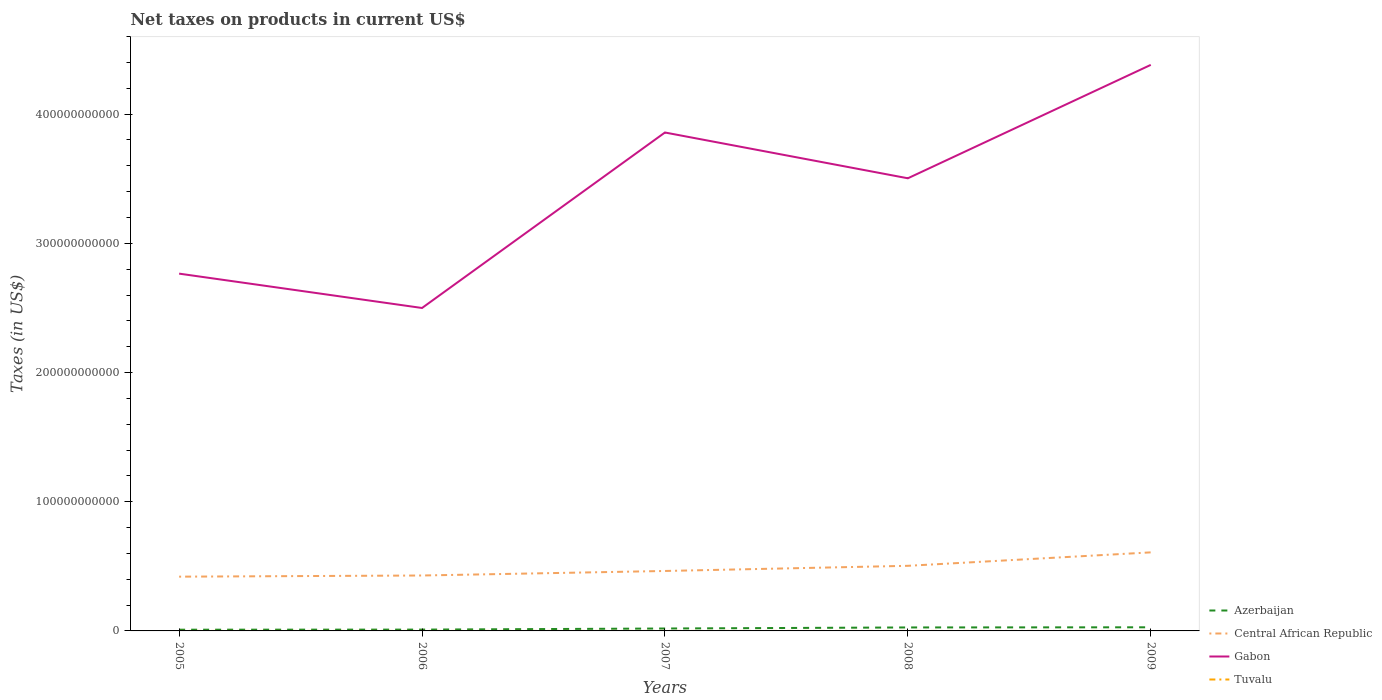Across all years, what is the maximum net taxes on products in Central African Republic?
Offer a terse response. 4.20e+1. In which year was the net taxes on products in Central African Republic maximum?
Your answer should be compact. 2005. What is the total net taxes on products in Azerbaijan in the graph?
Provide a short and direct response. -9.24e+08. What is the difference between the highest and the second highest net taxes on products in Central African Republic?
Make the answer very short. 1.88e+1. What is the difference between the highest and the lowest net taxes on products in Central African Republic?
Keep it short and to the point. 2. Is the net taxes on products in Tuvalu strictly greater than the net taxes on products in Azerbaijan over the years?
Your answer should be very brief. Yes. What is the difference between two consecutive major ticks on the Y-axis?
Offer a very short reply. 1.00e+11. Are the values on the major ticks of Y-axis written in scientific E-notation?
Provide a succinct answer. No. Does the graph contain any zero values?
Ensure brevity in your answer.  No. Where does the legend appear in the graph?
Offer a very short reply. Bottom right. What is the title of the graph?
Make the answer very short. Net taxes on products in current US$. Does "Northern Mariana Islands" appear as one of the legend labels in the graph?
Provide a succinct answer. No. What is the label or title of the Y-axis?
Give a very brief answer. Taxes (in US$). What is the Taxes (in US$) of Azerbaijan in 2005?
Ensure brevity in your answer.  9.46e+08. What is the Taxes (in US$) in Central African Republic in 2005?
Your answer should be very brief. 4.20e+1. What is the Taxes (in US$) of Gabon in 2005?
Your answer should be compact. 2.77e+11. What is the Taxes (in US$) of Tuvalu in 2005?
Make the answer very short. 2.79e+06. What is the Taxes (in US$) in Azerbaijan in 2006?
Ensure brevity in your answer.  1.02e+09. What is the Taxes (in US$) in Central African Republic in 2006?
Keep it short and to the point. 4.29e+1. What is the Taxes (in US$) of Gabon in 2006?
Your answer should be compact. 2.50e+11. What is the Taxes (in US$) in Tuvalu in 2006?
Offer a terse response. 2.62e+06. What is the Taxes (in US$) in Azerbaijan in 2007?
Your answer should be very brief. 1.87e+09. What is the Taxes (in US$) of Central African Republic in 2007?
Your answer should be very brief. 4.64e+1. What is the Taxes (in US$) in Gabon in 2007?
Your answer should be very brief. 3.86e+11. What is the Taxes (in US$) of Tuvalu in 2007?
Your response must be concise. 2.78e+06. What is the Taxes (in US$) in Azerbaijan in 2008?
Your response must be concise. 2.69e+09. What is the Taxes (in US$) in Central African Republic in 2008?
Your answer should be very brief. 5.04e+1. What is the Taxes (in US$) in Gabon in 2008?
Give a very brief answer. 3.50e+11. What is the Taxes (in US$) of Tuvalu in 2008?
Provide a succinct answer. 3.17e+06. What is the Taxes (in US$) in Azerbaijan in 2009?
Your response must be concise. 2.81e+09. What is the Taxes (in US$) of Central African Republic in 2009?
Provide a short and direct response. 6.08e+1. What is the Taxes (in US$) of Gabon in 2009?
Provide a succinct answer. 4.38e+11. What is the Taxes (in US$) of Tuvalu in 2009?
Ensure brevity in your answer.  2.72e+06. Across all years, what is the maximum Taxes (in US$) of Azerbaijan?
Provide a short and direct response. 2.81e+09. Across all years, what is the maximum Taxes (in US$) of Central African Republic?
Provide a succinct answer. 6.08e+1. Across all years, what is the maximum Taxes (in US$) in Gabon?
Offer a terse response. 4.38e+11. Across all years, what is the maximum Taxes (in US$) in Tuvalu?
Provide a succinct answer. 3.17e+06. Across all years, what is the minimum Taxes (in US$) in Azerbaijan?
Your answer should be compact. 9.46e+08. Across all years, what is the minimum Taxes (in US$) in Central African Republic?
Make the answer very short. 4.20e+1. Across all years, what is the minimum Taxes (in US$) of Gabon?
Provide a succinct answer. 2.50e+11. Across all years, what is the minimum Taxes (in US$) of Tuvalu?
Your answer should be very brief. 2.62e+06. What is the total Taxes (in US$) in Azerbaijan in the graph?
Offer a terse response. 9.34e+09. What is the total Taxes (in US$) of Central African Republic in the graph?
Your answer should be very brief. 2.42e+11. What is the total Taxes (in US$) of Gabon in the graph?
Ensure brevity in your answer.  1.70e+12. What is the total Taxes (in US$) in Tuvalu in the graph?
Provide a short and direct response. 1.41e+07. What is the difference between the Taxes (in US$) of Azerbaijan in 2005 and that in 2006?
Your response must be concise. -7.79e+07. What is the difference between the Taxes (in US$) in Central African Republic in 2005 and that in 2006?
Offer a very short reply. -9.00e+08. What is the difference between the Taxes (in US$) in Gabon in 2005 and that in 2006?
Offer a terse response. 2.66e+1. What is the difference between the Taxes (in US$) of Tuvalu in 2005 and that in 2006?
Your response must be concise. 1.68e+05. What is the difference between the Taxes (in US$) in Azerbaijan in 2005 and that in 2007?
Give a very brief answer. -9.24e+08. What is the difference between the Taxes (in US$) in Central African Republic in 2005 and that in 2007?
Give a very brief answer. -4.40e+09. What is the difference between the Taxes (in US$) in Gabon in 2005 and that in 2007?
Your answer should be very brief. -1.09e+11. What is the difference between the Taxes (in US$) of Tuvalu in 2005 and that in 2007?
Provide a succinct answer. 3800. What is the difference between the Taxes (in US$) of Azerbaijan in 2005 and that in 2008?
Offer a very short reply. -1.74e+09. What is the difference between the Taxes (in US$) of Central African Republic in 2005 and that in 2008?
Your answer should be very brief. -8.40e+09. What is the difference between the Taxes (in US$) in Gabon in 2005 and that in 2008?
Keep it short and to the point. -7.38e+1. What is the difference between the Taxes (in US$) of Tuvalu in 2005 and that in 2008?
Your answer should be very brief. -3.78e+05. What is the difference between the Taxes (in US$) of Azerbaijan in 2005 and that in 2009?
Offer a very short reply. -1.86e+09. What is the difference between the Taxes (in US$) of Central African Republic in 2005 and that in 2009?
Give a very brief answer. -1.88e+1. What is the difference between the Taxes (in US$) in Gabon in 2005 and that in 2009?
Your answer should be very brief. -1.62e+11. What is the difference between the Taxes (in US$) in Tuvalu in 2005 and that in 2009?
Provide a short and direct response. 7.28e+04. What is the difference between the Taxes (in US$) of Azerbaijan in 2006 and that in 2007?
Your answer should be compact. -8.46e+08. What is the difference between the Taxes (in US$) in Central African Republic in 2006 and that in 2007?
Keep it short and to the point. -3.50e+09. What is the difference between the Taxes (in US$) in Gabon in 2006 and that in 2007?
Provide a succinct answer. -1.36e+11. What is the difference between the Taxes (in US$) in Tuvalu in 2006 and that in 2007?
Give a very brief answer. -1.64e+05. What is the difference between the Taxes (in US$) in Azerbaijan in 2006 and that in 2008?
Give a very brief answer. -1.66e+09. What is the difference between the Taxes (in US$) in Central African Republic in 2006 and that in 2008?
Ensure brevity in your answer.  -7.50e+09. What is the difference between the Taxes (in US$) in Gabon in 2006 and that in 2008?
Offer a terse response. -1.00e+11. What is the difference between the Taxes (in US$) of Tuvalu in 2006 and that in 2008?
Give a very brief answer. -5.46e+05. What is the difference between the Taxes (in US$) in Azerbaijan in 2006 and that in 2009?
Your answer should be very brief. -1.79e+09. What is the difference between the Taxes (in US$) in Central African Republic in 2006 and that in 2009?
Make the answer very short. -1.79e+1. What is the difference between the Taxes (in US$) of Gabon in 2006 and that in 2009?
Your response must be concise. -1.88e+11. What is the difference between the Taxes (in US$) in Tuvalu in 2006 and that in 2009?
Offer a very short reply. -9.50e+04. What is the difference between the Taxes (in US$) of Azerbaijan in 2007 and that in 2008?
Your answer should be compact. -8.18e+08. What is the difference between the Taxes (in US$) in Central African Republic in 2007 and that in 2008?
Make the answer very short. -4.00e+09. What is the difference between the Taxes (in US$) of Gabon in 2007 and that in 2008?
Your response must be concise. 3.54e+1. What is the difference between the Taxes (in US$) of Tuvalu in 2007 and that in 2008?
Ensure brevity in your answer.  -3.82e+05. What is the difference between the Taxes (in US$) in Azerbaijan in 2007 and that in 2009?
Offer a very short reply. -9.40e+08. What is the difference between the Taxes (in US$) of Central African Republic in 2007 and that in 2009?
Offer a very short reply. -1.44e+1. What is the difference between the Taxes (in US$) of Gabon in 2007 and that in 2009?
Keep it short and to the point. -5.23e+1. What is the difference between the Taxes (in US$) in Tuvalu in 2007 and that in 2009?
Give a very brief answer. 6.90e+04. What is the difference between the Taxes (in US$) in Azerbaijan in 2008 and that in 2009?
Provide a short and direct response. -1.21e+08. What is the difference between the Taxes (in US$) of Central African Republic in 2008 and that in 2009?
Make the answer very short. -1.04e+1. What is the difference between the Taxes (in US$) in Gabon in 2008 and that in 2009?
Offer a terse response. -8.78e+1. What is the difference between the Taxes (in US$) of Tuvalu in 2008 and that in 2009?
Make the answer very short. 4.51e+05. What is the difference between the Taxes (in US$) of Azerbaijan in 2005 and the Taxes (in US$) of Central African Republic in 2006?
Your answer should be very brief. -4.20e+1. What is the difference between the Taxes (in US$) of Azerbaijan in 2005 and the Taxes (in US$) of Gabon in 2006?
Your answer should be very brief. -2.49e+11. What is the difference between the Taxes (in US$) of Azerbaijan in 2005 and the Taxes (in US$) of Tuvalu in 2006?
Offer a terse response. 9.44e+08. What is the difference between the Taxes (in US$) in Central African Republic in 2005 and the Taxes (in US$) in Gabon in 2006?
Your answer should be very brief. -2.08e+11. What is the difference between the Taxes (in US$) in Central African Republic in 2005 and the Taxes (in US$) in Tuvalu in 2006?
Provide a short and direct response. 4.20e+1. What is the difference between the Taxes (in US$) of Gabon in 2005 and the Taxes (in US$) of Tuvalu in 2006?
Provide a succinct answer. 2.77e+11. What is the difference between the Taxes (in US$) of Azerbaijan in 2005 and the Taxes (in US$) of Central African Republic in 2007?
Provide a short and direct response. -4.55e+1. What is the difference between the Taxes (in US$) in Azerbaijan in 2005 and the Taxes (in US$) in Gabon in 2007?
Offer a terse response. -3.85e+11. What is the difference between the Taxes (in US$) of Azerbaijan in 2005 and the Taxes (in US$) of Tuvalu in 2007?
Make the answer very short. 9.44e+08. What is the difference between the Taxes (in US$) in Central African Republic in 2005 and the Taxes (in US$) in Gabon in 2007?
Make the answer very short. -3.44e+11. What is the difference between the Taxes (in US$) of Central African Republic in 2005 and the Taxes (in US$) of Tuvalu in 2007?
Offer a terse response. 4.20e+1. What is the difference between the Taxes (in US$) of Gabon in 2005 and the Taxes (in US$) of Tuvalu in 2007?
Your answer should be very brief. 2.77e+11. What is the difference between the Taxes (in US$) of Azerbaijan in 2005 and the Taxes (in US$) of Central African Republic in 2008?
Offer a very short reply. -4.95e+1. What is the difference between the Taxes (in US$) in Azerbaijan in 2005 and the Taxes (in US$) in Gabon in 2008?
Offer a very short reply. -3.49e+11. What is the difference between the Taxes (in US$) of Azerbaijan in 2005 and the Taxes (in US$) of Tuvalu in 2008?
Provide a succinct answer. 9.43e+08. What is the difference between the Taxes (in US$) in Central African Republic in 2005 and the Taxes (in US$) in Gabon in 2008?
Your answer should be very brief. -3.08e+11. What is the difference between the Taxes (in US$) of Central African Republic in 2005 and the Taxes (in US$) of Tuvalu in 2008?
Your answer should be compact. 4.20e+1. What is the difference between the Taxes (in US$) of Gabon in 2005 and the Taxes (in US$) of Tuvalu in 2008?
Keep it short and to the point. 2.77e+11. What is the difference between the Taxes (in US$) in Azerbaijan in 2005 and the Taxes (in US$) in Central African Republic in 2009?
Keep it short and to the point. -5.99e+1. What is the difference between the Taxes (in US$) in Azerbaijan in 2005 and the Taxes (in US$) in Gabon in 2009?
Your response must be concise. -4.37e+11. What is the difference between the Taxes (in US$) of Azerbaijan in 2005 and the Taxes (in US$) of Tuvalu in 2009?
Give a very brief answer. 9.44e+08. What is the difference between the Taxes (in US$) in Central African Republic in 2005 and the Taxes (in US$) in Gabon in 2009?
Your answer should be compact. -3.96e+11. What is the difference between the Taxes (in US$) of Central African Republic in 2005 and the Taxes (in US$) of Tuvalu in 2009?
Give a very brief answer. 4.20e+1. What is the difference between the Taxes (in US$) of Gabon in 2005 and the Taxes (in US$) of Tuvalu in 2009?
Make the answer very short. 2.77e+11. What is the difference between the Taxes (in US$) of Azerbaijan in 2006 and the Taxes (in US$) of Central African Republic in 2007?
Keep it short and to the point. -4.54e+1. What is the difference between the Taxes (in US$) of Azerbaijan in 2006 and the Taxes (in US$) of Gabon in 2007?
Your response must be concise. -3.85e+11. What is the difference between the Taxes (in US$) of Azerbaijan in 2006 and the Taxes (in US$) of Tuvalu in 2007?
Provide a short and direct response. 1.02e+09. What is the difference between the Taxes (in US$) of Central African Republic in 2006 and the Taxes (in US$) of Gabon in 2007?
Offer a terse response. -3.43e+11. What is the difference between the Taxes (in US$) of Central African Republic in 2006 and the Taxes (in US$) of Tuvalu in 2007?
Make the answer very short. 4.29e+1. What is the difference between the Taxes (in US$) of Gabon in 2006 and the Taxes (in US$) of Tuvalu in 2007?
Give a very brief answer. 2.50e+11. What is the difference between the Taxes (in US$) of Azerbaijan in 2006 and the Taxes (in US$) of Central African Republic in 2008?
Give a very brief answer. -4.94e+1. What is the difference between the Taxes (in US$) in Azerbaijan in 2006 and the Taxes (in US$) in Gabon in 2008?
Your answer should be very brief. -3.49e+11. What is the difference between the Taxes (in US$) in Azerbaijan in 2006 and the Taxes (in US$) in Tuvalu in 2008?
Ensure brevity in your answer.  1.02e+09. What is the difference between the Taxes (in US$) of Central African Republic in 2006 and the Taxes (in US$) of Gabon in 2008?
Give a very brief answer. -3.07e+11. What is the difference between the Taxes (in US$) of Central African Republic in 2006 and the Taxes (in US$) of Tuvalu in 2008?
Provide a short and direct response. 4.29e+1. What is the difference between the Taxes (in US$) of Gabon in 2006 and the Taxes (in US$) of Tuvalu in 2008?
Provide a succinct answer. 2.50e+11. What is the difference between the Taxes (in US$) in Azerbaijan in 2006 and the Taxes (in US$) in Central African Republic in 2009?
Ensure brevity in your answer.  -5.98e+1. What is the difference between the Taxes (in US$) of Azerbaijan in 2006 and the Taxes (in US$) of Gabon in 2009?
Make the answer very short. -4.37e+11. What is the difference between the Taxes (in US$) in Azerbaijan in 2006 and the Taxes (in US$) in Tuvalu in 2009?
Ensure brevity in your answer.  1.02e+09. What is the difference between the Taxes (in US$) of Central African Republic in 2006 and the Taxes (in US$) of Gabon in 2009?
Your answer should be compact. -3.95e+11. What is the difference between the Taxes (in US$) of Central African Republic in 2006 and the Taxes (in US$) of Tuvalu in 2009?
Offer a terse response. 4.29e+1. What is the difference between the Taxes (in US$) in Gabon in 2006 and the Taxes (in US$) in Tuvalu in 2009?
Make the answer very short. 2.50e+11. What is the difference between the Taxes (in US$) in Azerbaijan in 2007 and the Taxes (in US$) in Central African Republic in 2008?
Provide a succinct answer. -4.85e+1. What is the difference between the Taxes (in US$) in Azerbaijan in 2007 and the Taxes (in US$) in Gabon in 2008?
Keep it short and to the point. -3.48e+11. What is the difference between the Taxes (in US$) of Azerbaijan in 2007 and the Taxes (in US$) of Tuvalu in 2008?
Your answer should be very brief. 1.87e+09. What is the difference between the Taxes (in US$) in Central African Republic in 2007 and the Taxes (in US$) in Gabon in 2008?
Give a very brief answer. -3.04e+11. What is the difference between the Taxes (in US$) in Central African Republic in 2007 and the Taxes (in US$) in Tuvalu in 2008?
Your answer should be very brief. 4.64e+1. What is the difference between the Taxes (in US$) of Gabon in 2007 and the Taxes (in US$) of Tuvalu in 2008?
Provide a short and direct response. 3.86e+11. What is the difference between the Taxes (in US$) in Azerbaijan in 2007 and the Taxes (in US$) in Central African Republic in 2009?
Offer a terse response. -5.89e+1. What is the difference between the Taxes (in US$) in Azerbaijan in 2007 and the Taxes (in US$) in Gabon in 2009?
Your response must be concise. -4.36e+11. What is the difference between the Taxes (in US$) of Azerbaijan in 2007 and the Taxes (in US$) of Tuvalu in 2009?
Offer a very short reply. 1.87e+09. What is the difference between the Taxes (in US$) of Central African Republic in 2007 and the Taxes (in US$) of Gabon in 2009?
Make the answer very short. -3.92e+11. What is the difference between the Taxes (in US$) of Central African Republic in 2007 and the Taxes (in US$) of Tuvalu in 2009?
Your response must be concise. 4.64e+1. What is the difference between the Taxes (in US$) of Gabon in 2007 and the Taxes (in US$) of Tuvalu in 2009?
Keep it short and to the point. 3.86e+11. What is the difference between the Taxes (in US$) in Azerbaijan in 2008 and the Taxes (in US$) in Central African Republic in 2009?
Give a very brief answer. -5.81e+1. What is the difference between the Taxes (in US$) of Azerbaijan in 2008 and the Taxes (in US$) of Gabon in 2009?
Offer a terse response. -4.35e+11. What is the difference between the Taxes (in US$) of Azerbaijan in 2008 and the Taxes (in US$) of Tuvalu in 2009?
Your answer should be compact. 2.69e+09. What is the difference between the Taxes (in US$) of Central African Republic in 2008 and the Taxes (in US$) of Gabon in 2009?
Your response must be concise. -3.88e+11. What is the difference between the Taxes (in US$) of Central African Republic in 2008 and the Taxes (in US$) of Tuvalu in 2009?
Provide a short and direct response. 5.04e+1. What is the difference between the Taxes (in US$) of Gabon in 2008 and the Taxes (in US$) of Tuvalu in 2009?
Your response must be concise. 3.50e+11. What is the average Taxes (in US$) in Azerbaijan per year?
Offer a very short reply. 1.87e+09. What is the average Taxes (in US$) of Central African Republic per year?
Your response must be concise. 4.85e+1. What is the average Taxes (in US$) of Gabon per year?
Ensure brevity in your answer.  3.40e+11. What is the average Taxes (in US$) in Tuvalu per year?
Your answer should be compact. 2.81e+06. In the year 2005, what is the difference between the Taxes (in US$) in Azerbaijan and Taxes (in US$) in Central African Republic?
Offer a terse response. -4.11e+1. In the year 2005, what is the difference between the Taxes (in US$) of Azerbaijan and Taxes (in US$) of Gabon?
Make the answer very short. -2.76e+11. In the year 2005, what is the difference between the Taxes (in US$) in Azerbaijan and Taxes (in US$) in Tuvalu?
Provide a short and direct response. 9.44e+08. In the year 2005, what is the difference between the Taxes (in US$) of Central African Republic and Taxes (in US$) of Gabon?
Your answer should be very brief. -2.35e+11. In the year 2005, what is the difference between the Taxes (in US$) in Central African Republic and Taxes (in US$) in Tuvalu?
Give a very brief answer. 4.20e+1. In the year 2005, what is the difference between the Taxes (in US$) in Gabon and Taxes (in US$) in Tuvalu?
Your answer should be compact. 2.77e+11. In the year 2006, what is the difference between the Taxes (in US$) in Azerbaijan and Taxes (in US$) in Central African Republic?
Your answer should be very brief. -4.19e+1. In the year 2006, what is the difference between the Taxes (in US$) in Azerbaijan and Taxes (in US$) in Gabon?
Provide a succinct answer. -2.49e+11. In the year 2006, what is the difference between the Taxes (in US$) of Azerbaijan and Taxes (in US$) of Tuvalu?
Make the answer very short. 1.02e+09. In the year 2006, what is the difference between the Taxes (in US$) in Central African Republic and Taxes (in US$) in Gabon?
Make the answer very short. -2.07e+11. In the year 2006, what is the difference between the Taxes (in US$) in Central African Republic and Taxes (in US$) in Tuvalu?
Your answer should be compact. 4.29e+1. In the year 2006, what is the difference between the Taxes (in US$) of Gabon and Taxes (in US$) of Tuvalu?
Your response must be concise. 2.50e+11. In the year 2007, what is the difference between the Taxes (in US$) in Azerbaijan and Taxes (in US$) in Central African Republic?
Keep it short and to the point. -4.45e+1. In the year 2007, what is the difference between the Taxes (in US$) of Azerbaijan and Taxes (in US$) of Gabon?
Your answer should be very brief. -3.84e+11. In the year 2007, what is the difference between the Taxes (in US$) of Azerbaijan and Taxes (in US$) of Tuvalu?
Your response must be concise. 1.87e+09. In the year 2007, what is the difference between the Taxes (in US$) in Central African Republic and Taxes (in US$) in Gabon?
Give a very brief answer. -3.39e+11. In the year 2007, what is the difference between the Taxes (in US$) in Central African Republic and Taxes (in US$) in Tuvalu?
Your response must be concise. 4.64e+1. In the year 2007, what is the difference between the Taxes (in US$) in Gabon and Taxes (in US$) in Tuvalu?
Your answer should be compact. 3.86e+11. In the year 2008, what is the difference between the Taxes (in US$) in Azerbaijan and Taxes (in US$) in Central African Republic?
Ensure brevity in your answer.  -4.77e+1. In the year 2008, what is the difference between the Taxes (in US$) of Azerbaijan and Taxes (in US$) of Gabon?
Offer a very short reply. -3.48e+11. In the year 2008, what is the difference between the Taxes (in US$) in Azerbaijan and Taxes (in US$) in Tuvalu?
Keep it short and to the point. 2.69e+09. In the year 2008, what is the difference between the Taxes (in US$) of Central African Republic and Taxes (in US$) of Gabon?
Provide a succinct answer. -3.00e+11. In the year 2008, what is the difference between the Taxes (in US$) of Central African Republic and Taxes (in US$) of Tuvalu?
Give a very brief answer. 5.04e+1. In the year 2008, what is the difference between the Taxes (in US$) in Gabon and Taxes (in US$) in Tuvalu?
Give a very brief answer. 3.50e+11. In the year 2009, what is the difference between the Taxes (in US$) of Azerbaijan and Taxes (in US$) of Central African Republic?
Provide a short and direct response. -5.80e+1. In the year 2009, what is the difference between the Taxes (in US$) of Azerbaijan and Taxes (in US$) of Gabon?
Your answer should be compact. -4.35e+11. In the year 2009, what is the difference between the Taxes (in US$) of Azerbaijan and Taxes (in US$) of Tuvalu?
Ensure brevity in your answer.  2.81e+09. In the year 2009, what is the difference between the Taxes (in US$) of Central African Republic and Taxes (in US$) of Gabon?
Your answer should be compact. -3.77e+11. In the year 2009, what is the difference between the Taxes (in US$) in Central African Republic and Taxes (in US$) in Tuvalu?
Your answer should be very brief. 6.08e+1. In the year 2009, what is the difference between the Taxes (in US$) of Gabon and Taxes (in US$) of Tuvalu?
Your response must be concise. 4.38e+11. What is the ratio of the Taxes (in US$) of Azerbaijan in 2005 to that in 2006?
Offer a very short reply. 0.92. What is the ratio of the Taxes (in US$) of Central African Republic in 2005 to that in 2006?
Ensure brevity in your answer.  0.98. What is the ratio of the Taxes (in US$) of Gabon in 2005 to that in 2006?
Keep it short and to the point. 1.11. What is the ratio of the Taxes (in US$) in Tuvalu in 2005 to that in 2006?
Provide a short and direct response. 1.06. What is the ratio of the Taxes (in US$) of Azerbaijan in 2005 to that in 2007?
Provide a succinct answer. 0.51. What is the ratio of the Taxes (in US$) in Central African Republic in 2005 to that in 2007?
Your answer should be very brief. 0.91. What is the ratio of the Taxes (in US$) of Gabon in 2005 to that in 2007?
Give a very brief answer. 0.72. What is the ratio of the Taxes (in US$) of Tuvalu in 2005 to that in 2007?
Your response must be concise. 1. What is the ratio of the Taxes (in US$) of Azerbaijan in 2005 to that in 2008?
Keep it short and to the point. 0.35. What is the ratio of the Taxes (in US$) of Central African Republic in 2005 to that in 2008?
Offer a very short reply. 0.83. What is the ratio of the Taxes (in US$) of Gabon in 2005 to that in 2008?
Ensure brevity in your answer.  0.79. What is the ratio of the Taxes (in US$) in Tuvalu in 2005 to that in 2008?
Ensure brevity in your answer.  0.88. What is the ratio of the Taxes (in US$) of Azerbaijan in 2005 to that in 2009?
Your answer should be very brief. 0.34. What is the ratio of the Taxes (in US$) in Central African Republic in 2005 to that in 2009?
Your response must be concise. 0.69. What is the ratio of the Taxes (in US$) in Gabon in 2005 to that in 2009?
Provide a short and direct response. 0.63. What is the ratio of the Taxes (in US$) in Tuvalu in 2005 to that in 2009?
Provide a succinct answer. 1.03. What is the ratio of the Taxes (in US$) of Azerbaijan in 2006 to that in 2007?
Give a very brief answer. 0.55. What is the ratio of the Taxes (in US$) of Central African Republic in 2006 to that in 2007?
Make the answer very short. 0.92. What is the ratio of the Taxes (in US$) in Gabon in 2006 to that in 2007?
Your answer should be compact. 0.65. What is the ratio of the Taxes (in US$) in Tuvalu in 2006 to that in 2007?
Your answer should be compact. 0.94. What is the ratio of the Taxes (in US$) in Azerbaijan in 2006 to that in 2008?
Your answer should be compact. 0.38. What is the ratio of the Taxes (in US$) in Central African Republic in 2006 to that in 2008?
Give a very brief answer. 0.85. What is the ratio of the Taxes (in US$) of Gabon in 2006 to that in 2008?
Give a very brief answer. 0.71. What is the ratio of the Taxes (in US$) in Tuvalu in 2006 to that in 2008?
Your answer should be very brief. 0.83. What is the ratio of the Taxes (in US$) of Azerbaijan in 2006 to that in 2009?
Give a very brief answer. 0.36. What is the ratio of the Taxes (in US$) in Central African Republic in 2006 to that in 2009?
Your answer should be compact. 0.71. What is the ratio of the Taxes (in US$) of Gabon in 2006 to that in 2009?
Provide a succinct answer. 0.57. What is the ratio of the Taxes (in US$) in Azerbaijan in 2007 to that in 2008?
Ensure brevity in your answer.  0.7. What is the ratio of the Taxes (in US$) in Central African Republic in 2007 to that in 2008?
Offer a very short reply. 0.92. What is the ratio of the Taxes (in US$) of Gabon in 2007 to that in 2008?
Keep it short and to the point. 1.1. What is the ratio of the Taxes (in US$) in Tuvalu in 2007 to that in 2008?
Provide a short and direct response. 0.88. What is the ratio of the Taxes (in US$) in Azerbaijan in 2007 to that in 2009?
Your response must be concise. 0.67. What is the ratio of the Taxes (in US$) of Central African Republic in 2007 to that in 2009?
Provide a short and direct response. 0.76. What is the ratio of the Taxes (in US$) in Gabon in 2007 to that in 2009?
Your response must be concise. 0.88. What is the ratio of the Taxes (in US$) in Tuvalu in 2007 to that in 2009?
Offer a terse response. 1.03. What is the ratio of the Taxes (in US$) of Azerbaijan in 2008 to that in 2009?
Your answer should be very brief. 0.96. What is the ratio of the Taxes (in US$) in Central African Republic in 2008 to that in 2009?
Keep it short and to the point. 0.83. What is the ratio of the Taxes (in US$) of Gabon in 2008 to that in 2009?
Give a very brief answer. 0.8. What is the ratio of the Taxes (in US$) of Tuvalu in 2008 to that in 2009?
Your answer should be compact. 1.17. What is the difference between the highest and the second highest Taxes (in US$) of Azerbaijan?
Provide a short and direct response. 1.21e+08. What is the difference between the highest and the second highest Taxes (in US$) of Central African Republic?
Offer a terse response. 1.04e+1. What is the difference between the highest and the second highest Taxes (in US$) of Gabon?
Your answer should be very brief. 5.23e+1. What is the difference between the highest and the second highest Taxes (in US$) of Tuvalu?
Your answer should be compact. 3.78e+05. What is the difference between the highest and the lowest Taxes (in US$) in Azerbaijan?
Ensure brevity in your answer.  1.86e+09. What is the difference between the highest and the lowest Taxes (in US$) of Central African Republic?
Provide a short and direct response. 1.88e+1. What is the difference between the highest and the lowest Taxes (in US$) of Gabon?
Your response must be concise. 1.88e+11. What is the difference between the highest and the lowest Taxes (in US$) in Tuvalu?
Offer a terse response. 5.46e+05. 